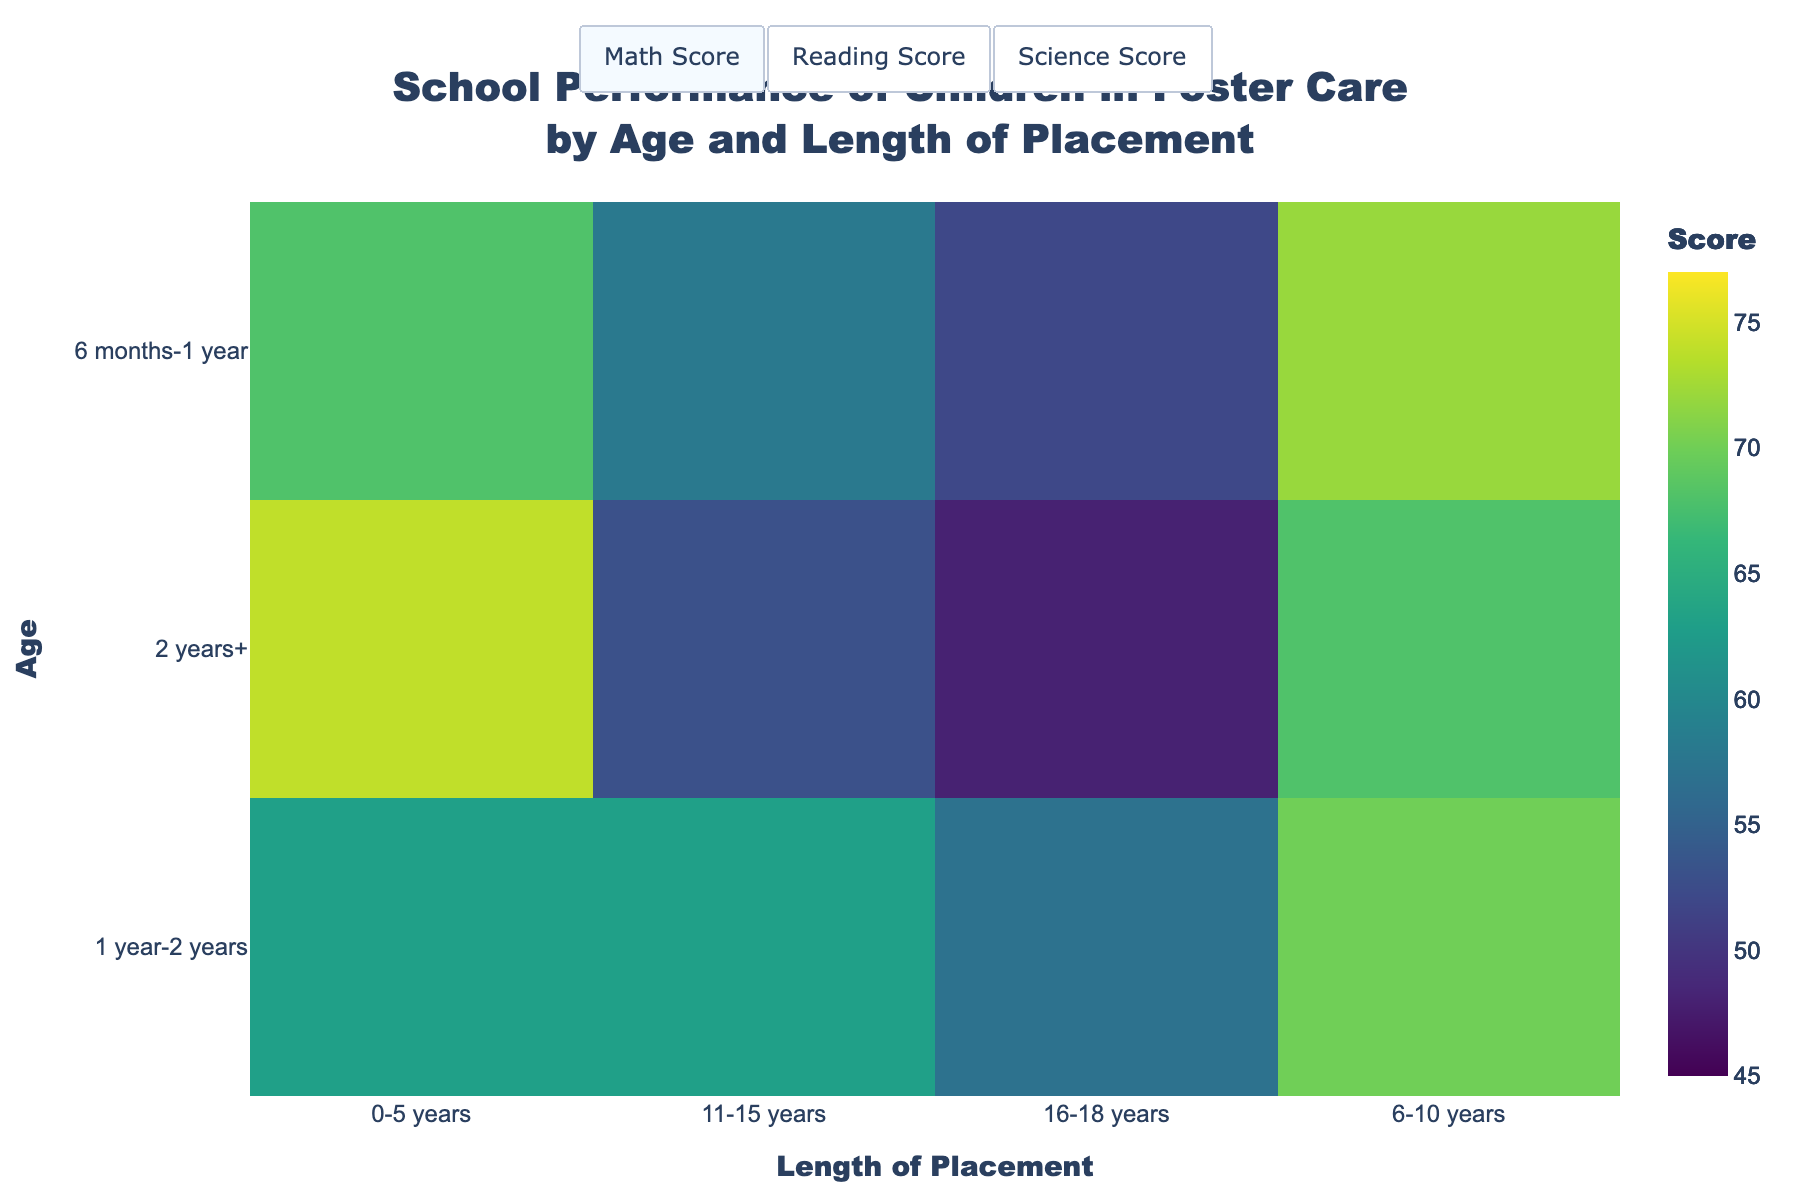What is the title of the heatmap? The title of the heatmap is usually displayed prominently at the top of the figure. In this case, it states, "School Performance of Children in Foster Care by Age and Length of Placement."
Answer: School Performance of Children in Foster Care by Age and Length of Placement Which age group performs the best in Math within 2 years+ of placement? To find this, locate the Math Score heatmap, then identify the values for the "2 years+" length of placement. The highest value is for the age group "0-5 years," which shows a score of 72.
Answer: 0-5 years What is the difference in the Reading Score between children aged 0-5 years and 11-15 years in the 6 months-1 year placement group? First, find the Reading Score for 0-5 years (70) and for 11-15 years (60) within the 6 months-1 year group. Subtract the lower value from the higher value: 70 - 60 = 10.
Answer: 10 What is the lowest Science Score recorded in the heatmap? To find the lowest Science Score, look for the smallest value across all cells in the Science Score heatmap. The lowest value is 48 for the "16-18 years" age group in the "2 years+" placement.
Answer: 48 Which placement length shows a consistent performance across all subjects for 6-10 years old? Examine the heatmaps for all subjects (Math, Reading, Science) and focus on the 6-10 years old category. All scores for "1 year-2 years" placement length are relatively consistent at 68 (Math), 73 (Reading), and 70 (Science).
Answer: 1 year-2 years How do the Math Scores compare between the youngest and oldest children within the 1 year-2 years placement? Compare Math Scores for 0-5 years (60) and 16-18 years (55) within 1 year-2 years placement. The score for 0-5 years is higher by 5 points compared to 16-18 years.
Answer: The youngest (0-5 years) score is higher by 5 points What is the average Science Score for children aged 6-10 years across all placement lengths? Collect all Science Scores for 6-10 years old: 72 (6 months-1 year), 70 (1 year-2 years), and 68 (2 years+). Then calculate the average: (72 + 70 + 68) / 3 = 70.
Answer: 70 For which age and placement combination do children have the highest Reading Score? Look at the Reading Score heatmap and find the highest value. It is 77, for the "0-5 years" age group in the "2 years+" placement.
Answer: 0-5 years, 2 years+ How does the academic performance trend as children age within the 6 months-1 year placement? To analyze this, compare the scores of each subject for each age group within the 6 months-1 year placement. The scores decrease as age increases: 0-5 years (Math 65, Reading 70, Science 68), 6-10 years (Math 70, Reading 75, Science 72), 11-15 years (Math 55, Reading 60, Science 58), and 16-18 years (Math 50, Reading 55, Science 52). The trend shows that academic performance declines with age.
Answer: Performance declines with age 